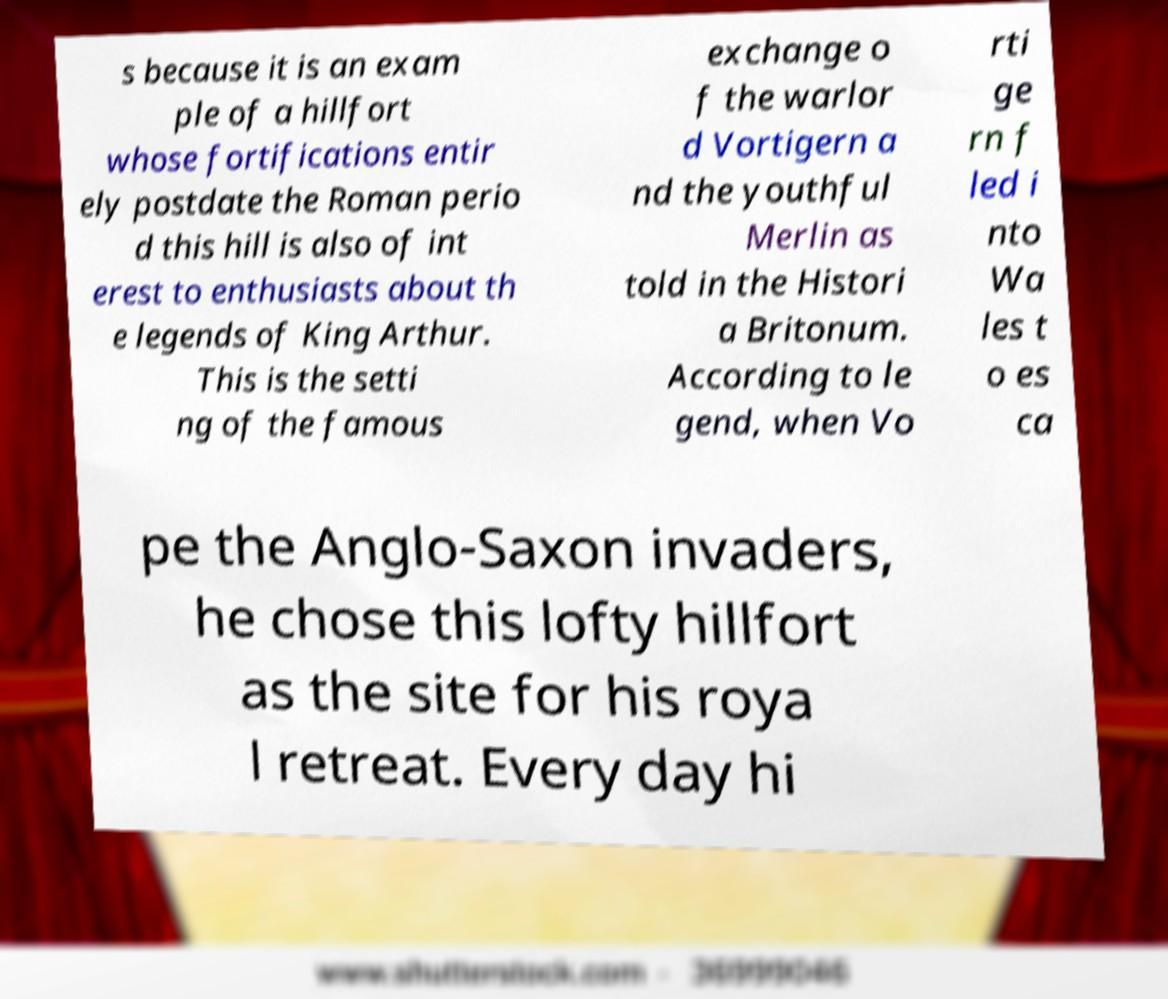What messages or text are displayed in this image? I need them in a readable, typed format. s because it is an exam ple of a hillfort whose fortifications entir ely postdate the Roman perio d this hill is also of int erest to enthusiasts about th e legends of King Arthur. This is the setti ng of the famous exchange o f the warlor d Vortigern a nd the youthful Merlin as told in the Histori a Britonum. According to le gend, when Vo rti ge rn f led i nto Wa les t o es ca pe the Anglo-Saxon invaders, he chose this lofty hillfort as the site for his roya l retreat. Every day hi 